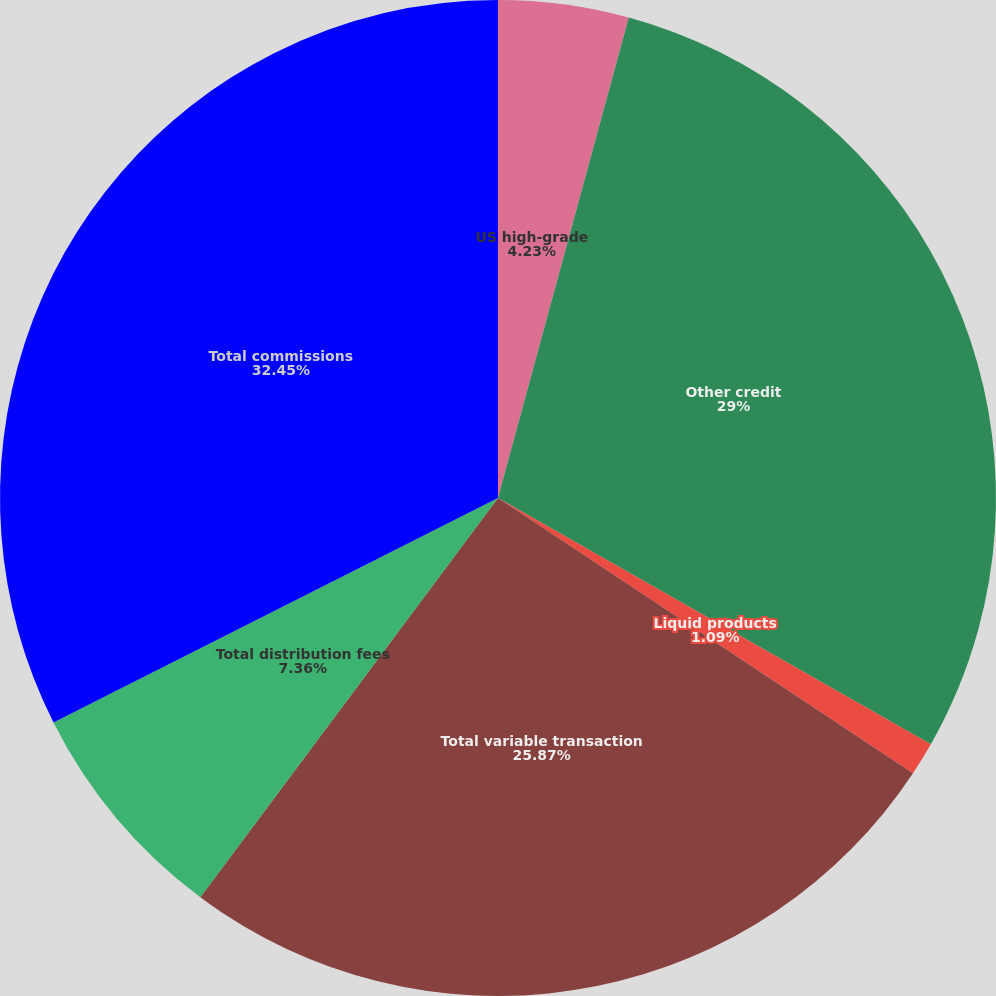<chart> <loc_0><loc_0><loc_500><loc_500><pie_chart><fcel>US high-grade<fcel>Other credit<fcel>Liquid products<fcel>Total variable transaction<fcel>Total distribution fees<fcel>Total commissions<nl><fcel>4.23%<fcel>29.0%<fcel>1.09%<fcel>25.87%<fcel>7.36%<fcel>32.44%<nl></chart> 